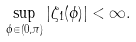<formula> <loc_0><loc_0><loc_500><loc_500>\sup _ { \phi \in ( 0 , \pi ) } | \zeta _ { 1 } ( \phi ) | < \infty .</formula> 